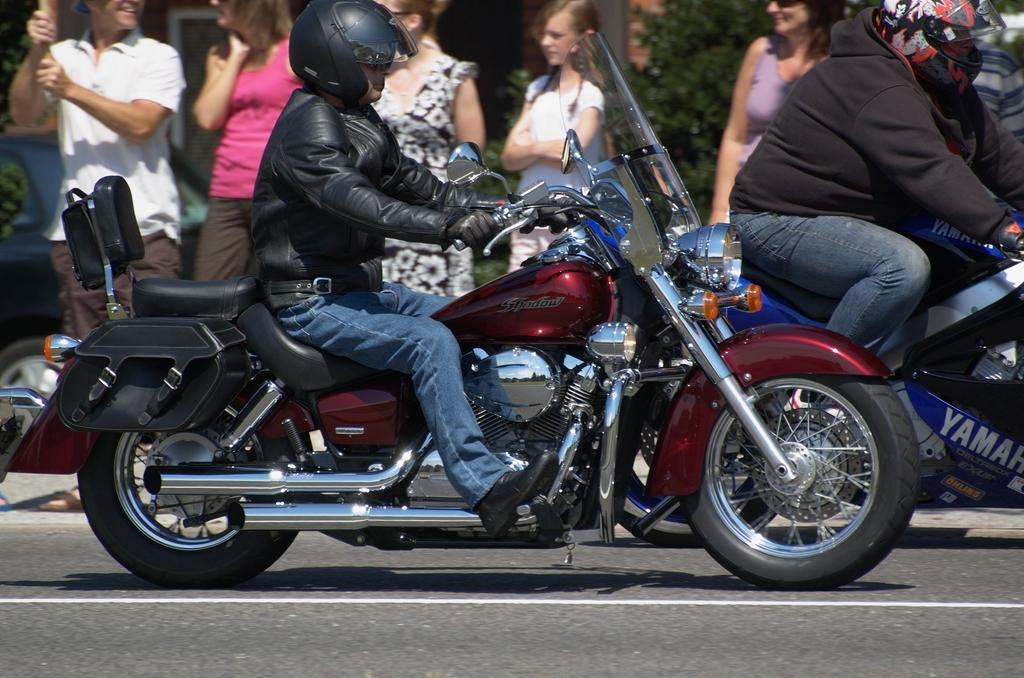Can you describe this image briefly? In this image I can see a man riding a bike. At the background there are few people standing. 